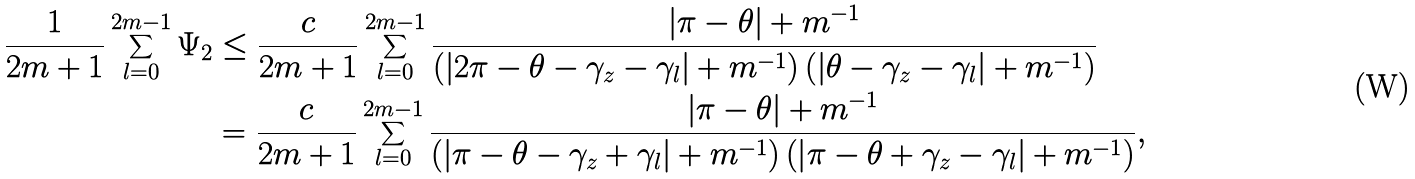<formula> <loc_0><loc_0><loc_500><loc_500>\frac { 1 } { 2 m + 1 } \sum _ { l = 0 } ^ { 2 m - 1 } \Psi _ { 2 } & \leq \frac { c } { 2 m + 1 } \sum _ { l = 0 } ^ { 2 m - 1 } \frac { \left | \pi - \theta \right | + m ^ { - 1 } } { \left ( \left | 2 \pi - \theta - \gamma _ { z } - \gamma _ { l } \right | + m ^ { - 1 } \right ) \left ( \left | \theta - \gamma _ { z } - \gamma _ { l } \right | + m ^ { - 1 } \right ) } \\ & = \frac { c } { 2 m + 1 } \sum _ { l = 0 } ^ { 2 m - 1 } \frac { \left | \pi - \theta \right | + m ^ { - 1 } } { \left ( \left | \pi - \theta - \gamma _ { z } + \gamma _ { l } \right | + m ^ { - 1 } \right ) \left ( \left | \pi - \theta + \gamma _ { z } - \gamma _ { l } \right | + m ^ { - 1 } \right ) } ,</formula> 